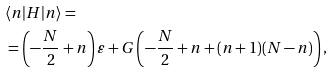Convert formula to latex. <formula><loc_0><loc_0><loc_500><loc_500>& \langle n | H | n \rangle = \\ & = \left ( - \frac { N } { 2 } + n \right ) \varepsilon + G \left ( - \frac { N } { 2 } + n + ( n + 1 ) ( N - n ) \right ) ,</formula> 